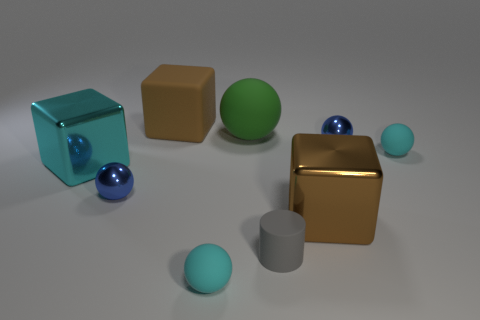Subtract all green balls. How many balls are left? 4 Subtract all green matte spheres. How many spheres are left? 4 Subtract 1 spheres. How many spheres are left? 4 Subtract all brown balls. Subtract all gray blocks. How many balls are left? 5 Add 1 green matte things. How many objects exist? 10 Subtract all blocks. How many objects are left? 6 Subtract all cyan spheres. Subtract all metal balls. How many objects are left? 5 Add 6 large green things. How many large green things are left? 7 Add 7 red shiny spheres. How many red shiny spheres exist? 7 Subtract 0 gray balls. How many objects are left? 9 